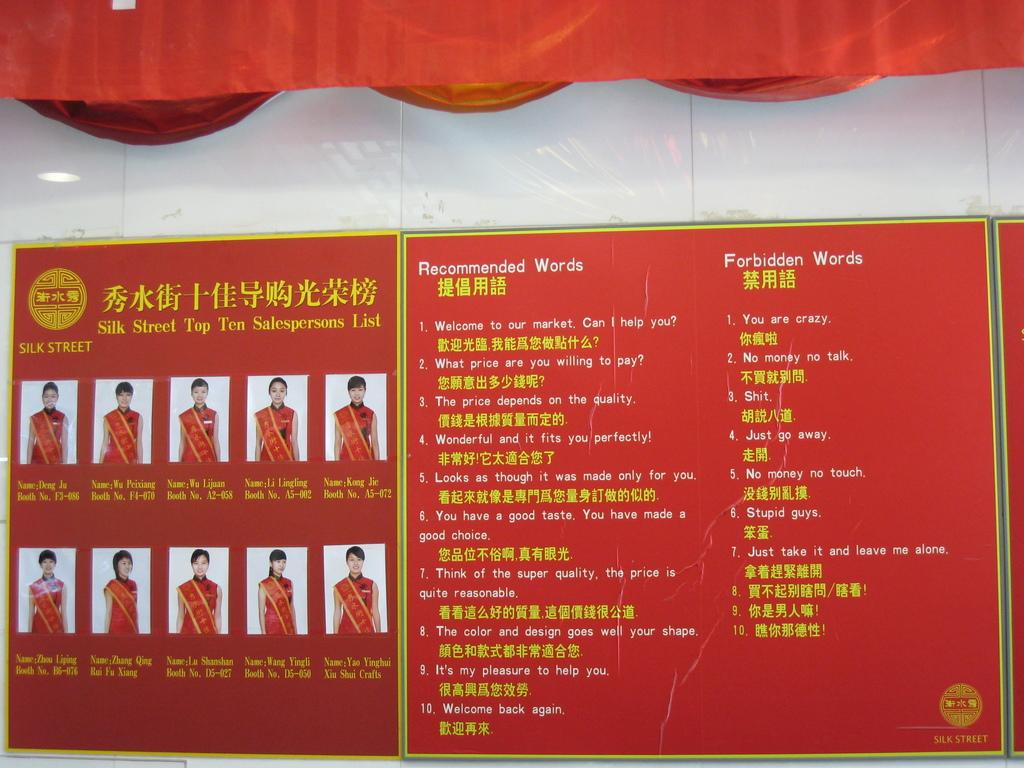<image>
Describe the image concisely. A sign for Silk Street shows the recommended and forbidden words. 